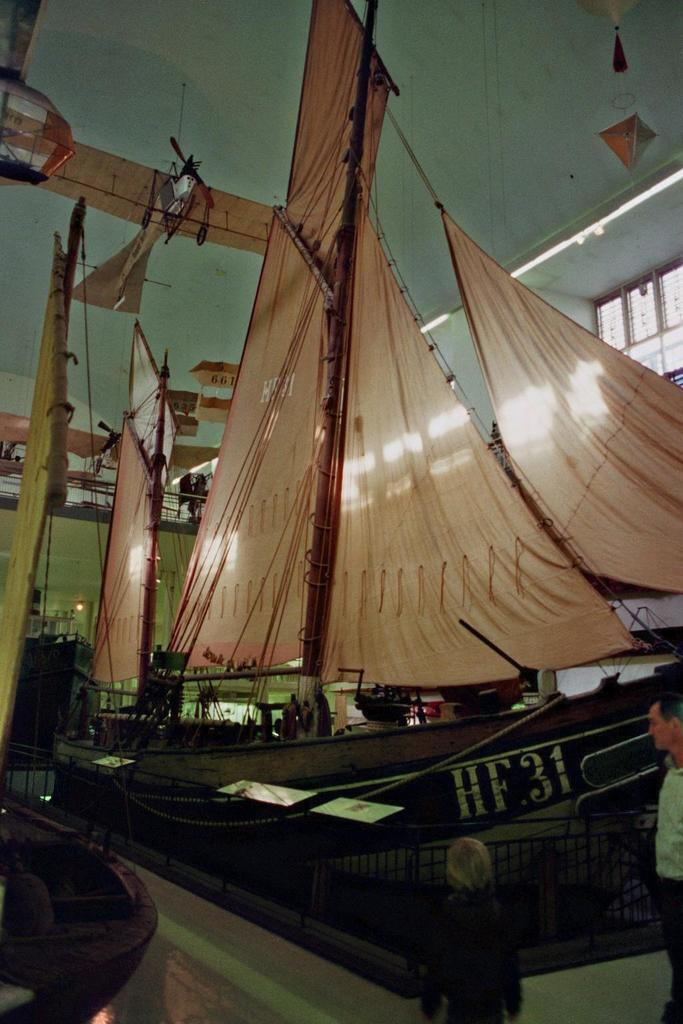Who or what can be seen in the image? There are people in the image. What type of barrier is present in the image? There is a metal fence in the image. What type of vehicles are visible in the image? There are boats in the image. What is visible at the top of the image? There are lights visible at the top of the image. What type of cord is being used to power the boats in the image? There is no cord visible in the image, and the boats' power source is not mentioned. 